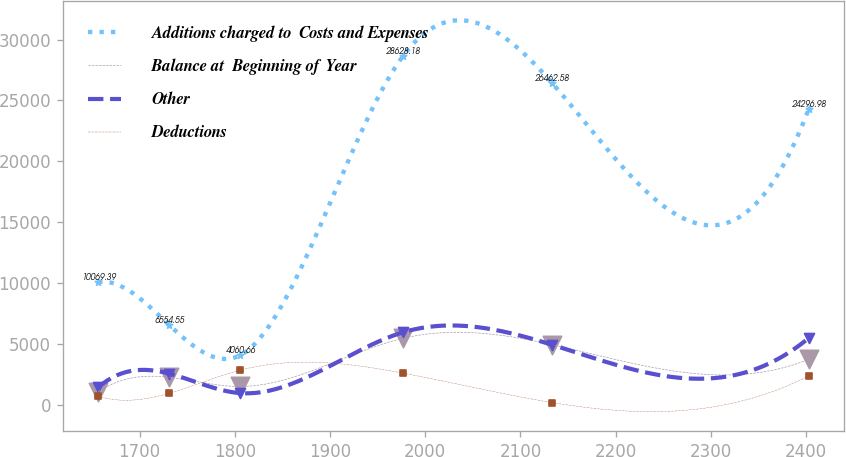<chart> <loc_0><loc_0><loc_500><loc_500><line_chart><ecel><fcel>Additions charged to  Costs and Expenses<fcel>Balance at  Beginning of Year<fcel>Other<fcel>Deductions<nl><fcel>1656.34<fcel>10069.4<fcel>1053.29<fcel>1414.19<fcel>695.49<nl><fcel>1730.99<fcel>6554.55<fcel>2248.44<fcel>2553.31<fcel>936.34<nl><fcel>1805.64<fcel>4060.66<fcel>1492.82<fcel>949.46<fcel>2835.98<nl><fcel>1976.38<fcel>28628.2<fcel>5448.61<fcel>5940.06<fcel>2595.13<nl><fcel>2132.95<fcel>26462.6<fcel>4938.16<fcel>4928.26<fcel>174.44<nl><fcel>2402.82<fcel>24297<fcel>3725.24<fcel>5475.33<fcel>2354.28<nl></chart> 